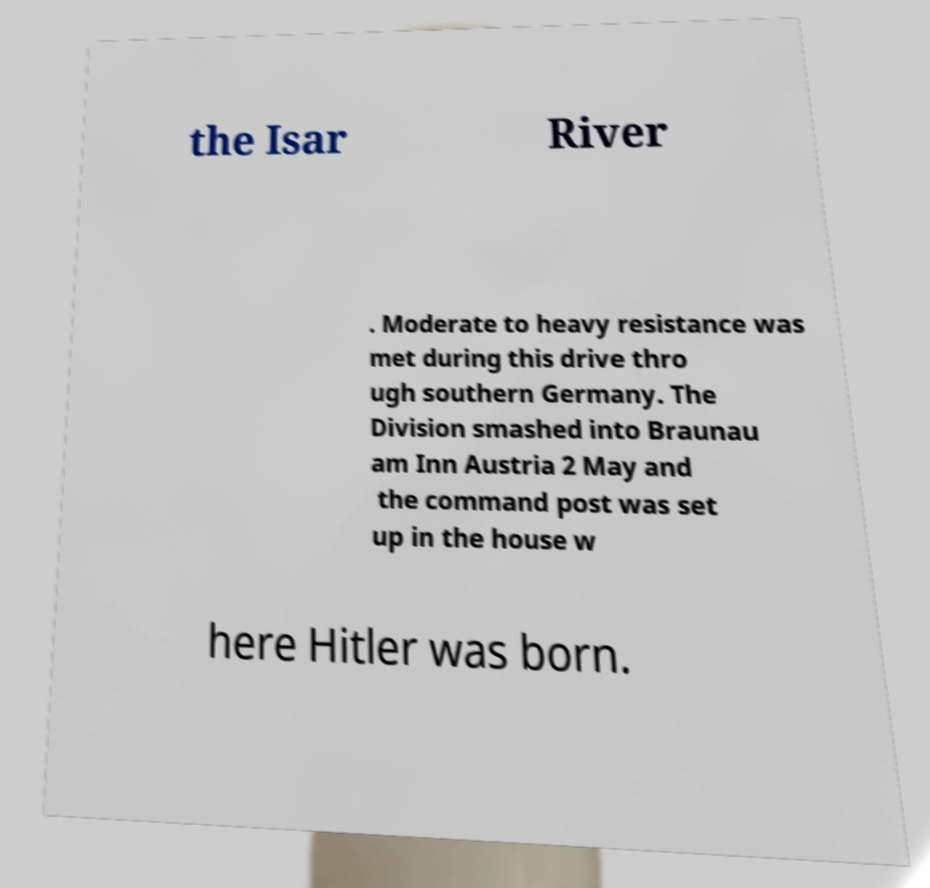For documentation purposes, I need the text within this image transcribed. Could you provide that? the Isar River . Moderate to heavy resistance was met during this drive thro ugh southern Germany. The Division smashed into Braunau am Inn Austria 2 May and the command post was set up in the house w here Hitler was born. 